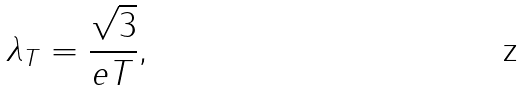Convert formula to latex. <formula><loc_0><loc_0><loc_500><loc_500>\lambda _ { T } = \frac { \sqrt { 3 } } { e T } ,</formula> 